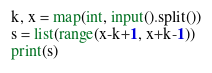<code> <loc_0><loc_0><loc_500><loc_500><_Python_>k, x = map(int, input().split())
s = list(range(x-k+1, x+k-1))
print(s)</code> 